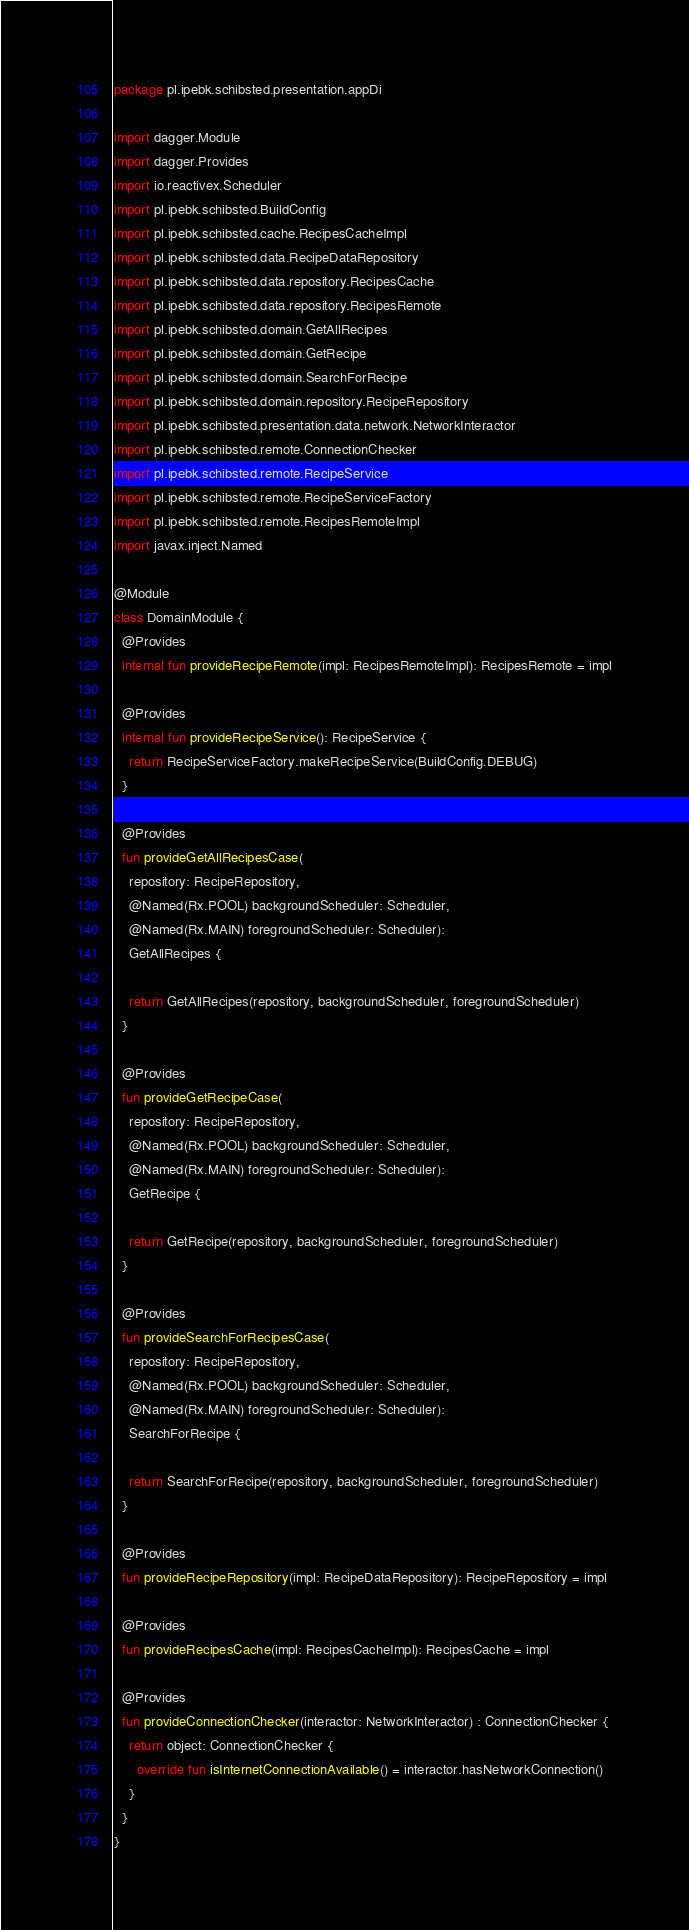<code> <loc_0><loc_0><loc_500><loc_500><_Kotlin_>package pl.ipebk.schibsted.presentation.appDi

import dagger.Module
import dagger.Provides
import io.reactivex.Scheduler
import pl.ipebk.schibsted.BuildConfig
import pl.ipebk.schibsted.cache.RecipesCacheImpl
import pl.ipebk.schibsted.data.RecipeDataRepository
import pl.ipebk.schibsted.data.repository.RecipesCache
import pl.ipebk.schibsted.data.repository.RecipesRemote
import pl.ipebk.schibsted.domain.GetAllRecipes
import pl.ipebk.schibsted.domain.GetRecipe
import pl.ipebk.schibsted.domain.SearchForRecipe
import pl.ipebk.schibsted.domain.repository.RecipeRepository
import pl.ipebk.schibsted.presentation.data.network.NetworkInteractor
import pl.ipebk.schibsted.remote.ConnectionChecker
import pl.ipebk.schibsted.remote.RecipeService
import pl.ipebk.schibsted.remote.RecipeServiceFactory
import pl.ipebk.schibsted.remote.RecipesRemoteImpl
import javax.inject.Named

@Module
class DomainModule {
  @Provides
  internal fun provideRecipeRemote(impl: RecipesRemoteImpl): RecipesRemote = impl

  @Provides
  internal fun provideRecipeService(): RecipeService {
    return RecipeServiceFactory.makeRecipeService(BuildConfig.DEBUG)
  }

  @Provides
  fun provideGetAllRecipesCase(
    repository: RecipeRepository,
    @Named(Rx.POOL) backgroundScheduler: Scheduler,
    @Named(Rx.MAIN) foregroundScheduler: Scheduler):
    GetAllRecipes {

    return GetAllRecipes(repository, backgroundScheduler, foregroundScheduler)
  }

  @Provides
  fun provideGetRecipeCase(
    repository: RecipeRepository,
    @Named(Rx.POOL) backgroundScheduler: Scheduler,
    @Named(Rx.MAIN) foregroundScheduler: Scheduler):
    GetRecipe {

    return GetRecipe(repository, backgroundScheduler, foregroundScheduler)
  }

  @Provides
  fun provideSearchForRecipesCase(
    repository: RecipeRepository,
    @Named(Rx.POOL) backgroundScheduler: Scheduler,
    @Named(Rx.MAIN) foregroundScheduler: Scheduler):
    SearchForRecipe {

    return SearchForRecipe(repository, backgroundScheduler, foregroundScheduler)
  }

  @Provides
  fun provideRecipeRepository(impl: RecipeDataRepository): RecipeRepository = impl

  @Provides
  fun provideRecipesCache(impl: RecipesCacheImpl): RecipesCache = impl

  @Provides
  fun provideConnectionChecker(interactor: NetworkInteractor) : ConnectionChecker {
    return object: ConnectionChecker {
      override fun isInternetConnectionAvailable() = interactor.hasNetworkConnection()
    }
  }
}</code> 